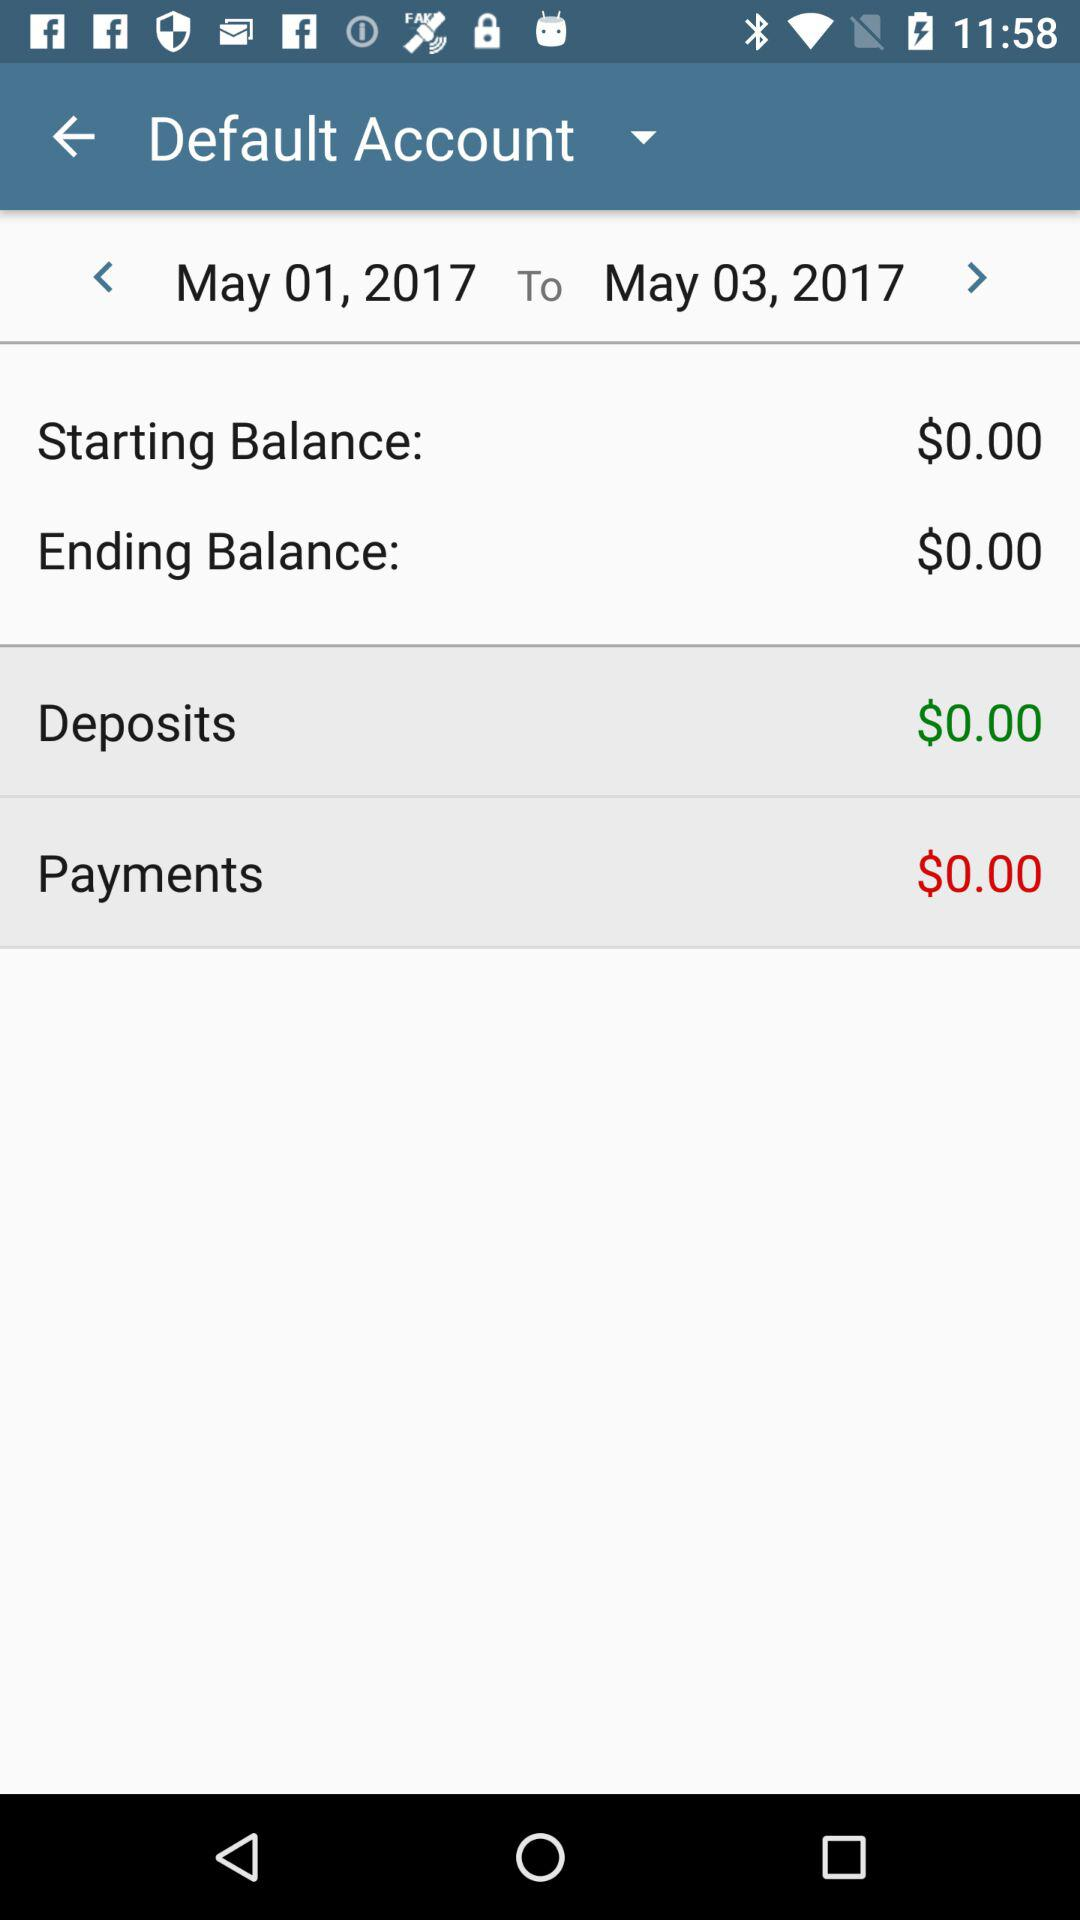What is the ending balance? The ending balance is $0.00. 